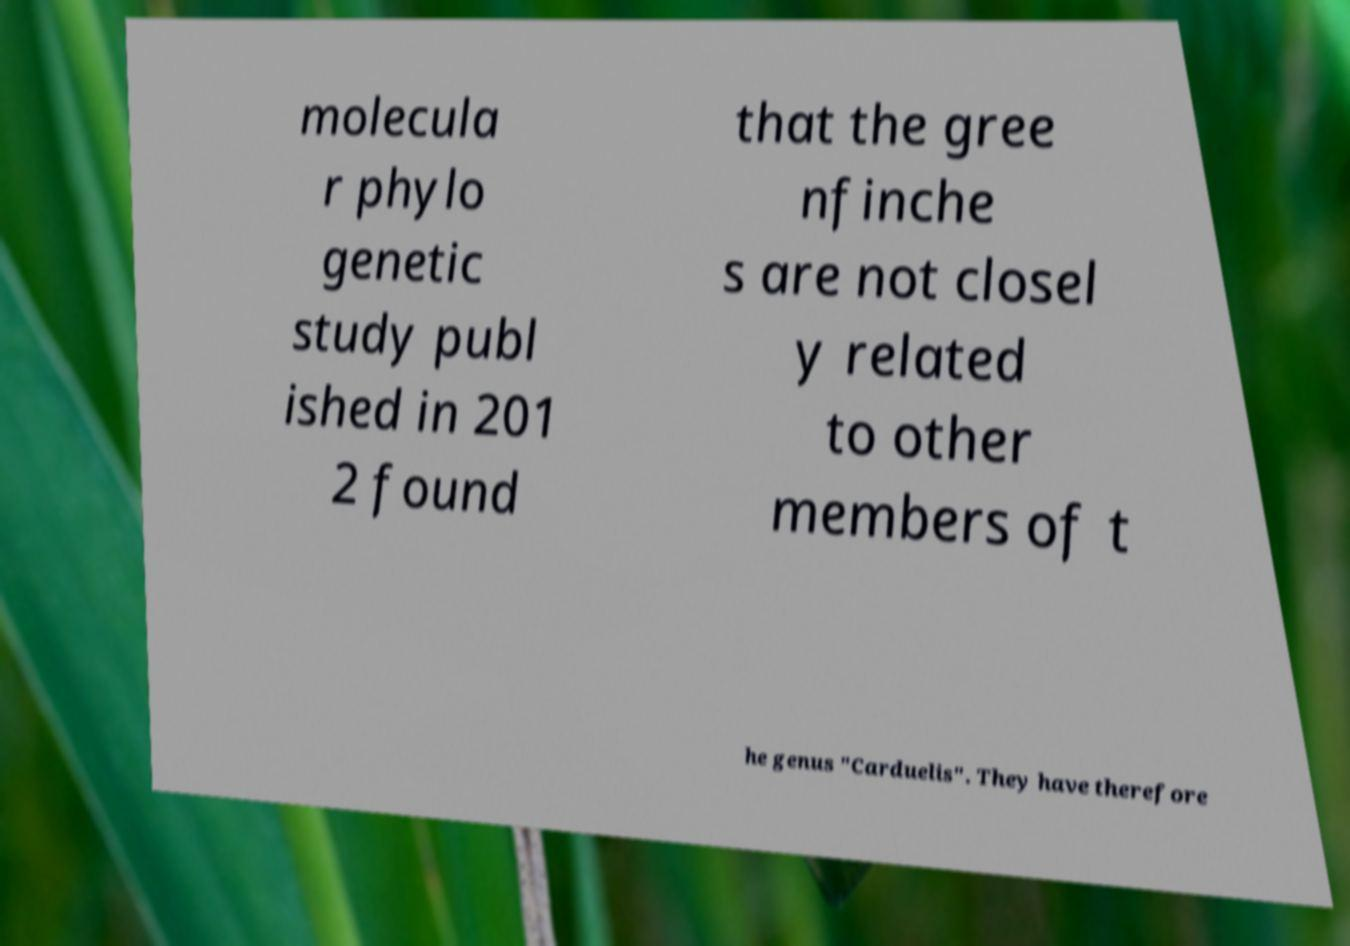For documentation purposes, I need the text within this image transcribed. Could you provide that? molecula r phylo genetic study publ ished in 201 2 found that the gree nfinche s are not closel y related to other members of t he genus "Carduelis". They have therefore 